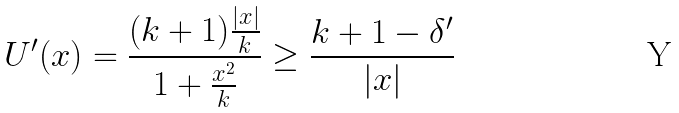Convert formula to latex. <formula><loc_0><loc_0><loc_500><loc_500>U ^ { \prime } ( x ) = \frac { ( k + 1 ) \frac { | x | } { k } } { 1 + \frac { x ^ { 2 } } { k } } \geq \frac { k + 1 - \delta ^ { \prime } } { | x | }</formula> 